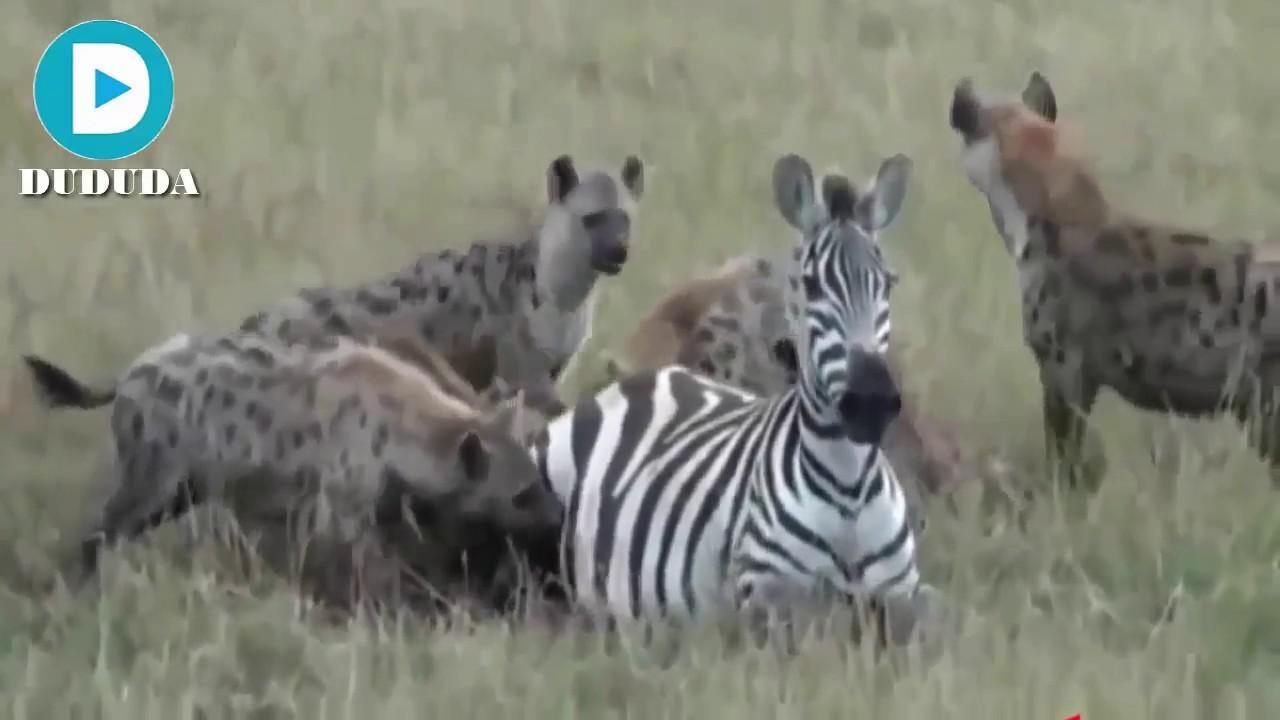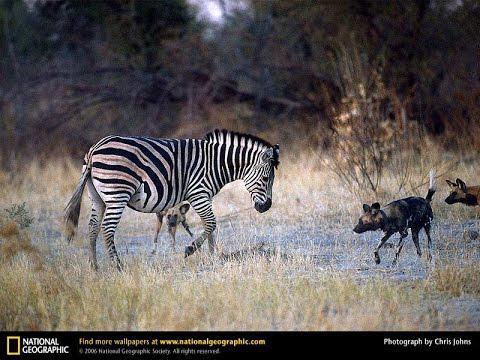The first image is the image on the left, the second image is the image on the right. Analyze the images presented: Is the assertion "A hyena attacks a zebra that is in the water." valid? Answer yes or no. No. 